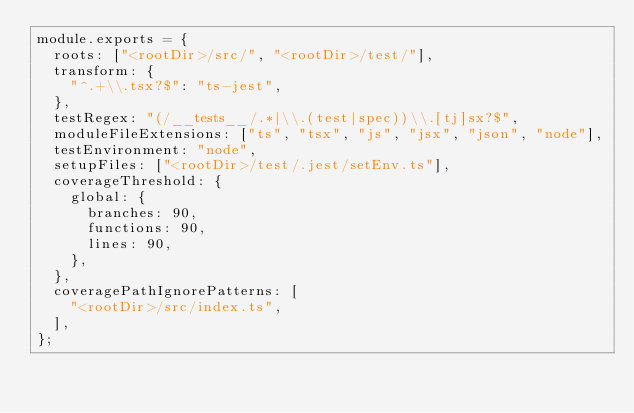Convert code to text. <code><loc_0><loc_0><loc_500><loc_500><_JavaScript_>module.exports = {
  roots: ["<rootDir>/src/", "<rootDir>/test/"],
  transform: {
    "^.+\\.tsx?$": "ts-jest",
  },
  testRegex: "(/__tests__/.*|\\.(test|spec))\\.[tj]sx?$",
  moduleFileExtensions: ["ts", "tsx", "js", "jsx", "json", "node"],
  testEnvironment: "node",
  setupFiles: ["<rootDir>/test/.jest/setEnv.ts"],
  coverageThreshold: {
    global: {
      branches: 90,
      functions: 90,
      lines: 90,
    },
  },
  coveragePathIgnorePatterns: [
    "<rootDir>/src/index.ts",
  ],
};
</code> 